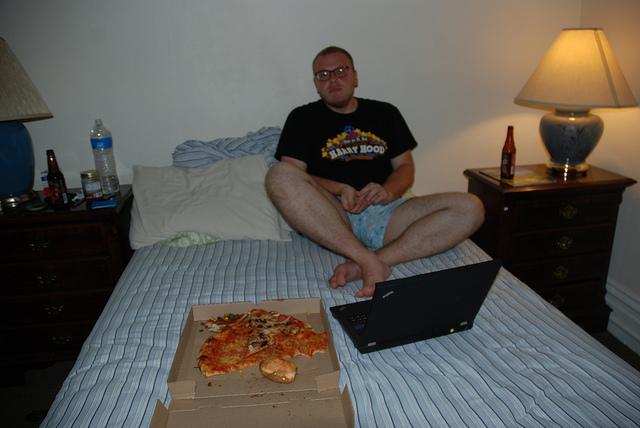Was the guy drinking beer in his room?
Answer briefly. Yes. How many laptops are pictured?
Quick response, please. 1. Is this man wearing glasses?
Be succinct. Yes. 